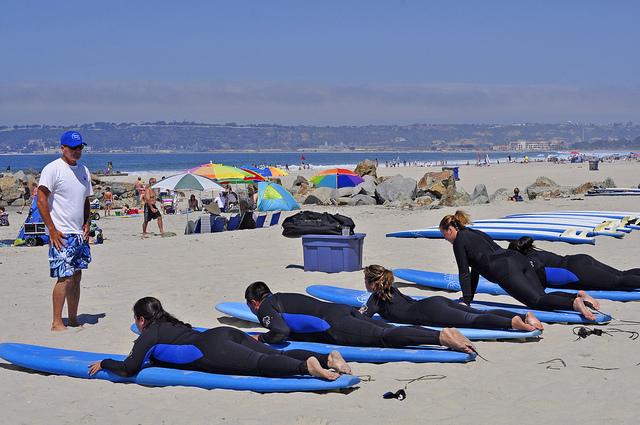What color is the board?
Write a very short answer. Blue. Do people have on wetsuits?
Write a very short answer. Yes. Why are some people laying on the sand?
Short answer required. Surfing. How many umbrellas are rainbow?
Write a very short answer. 3. What are the colors of umbrellas?
Concise answer only. Rainbow. What color are the trash cans?
Concise answer only. Blue. 